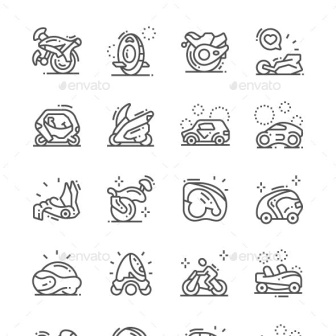What can you say about the style and design of these transportation icons? The icons adopt a clean, minimalistic line art style, which is both aesthetically pleasing and functionally effective. Each icon is rendered with precise lines and subtle detailing that convey the essence of each mode of transportation without unnecessary complexity. The monochromatic black and white color scheme enhances the timeless and classic feel of the design. Dots and lines are used creatively to suggest movement and action, adding a dynamic quality to the static icons. The uniform style across all icons creates a cohesive visual grouping, making it easy to interpret and understand the collection as a whole. 